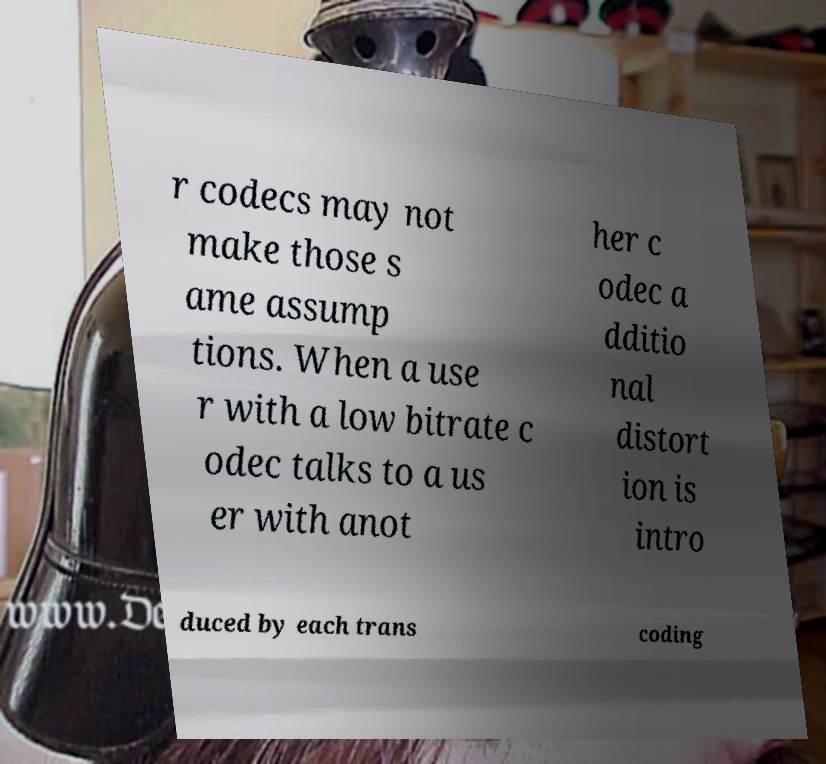Please identify and transcribe the text found in this image. r codecs may not make those s ame assump tions. When a use r with a low bitrate c odec talks to a us er with anot her c odec a dditio nal distort ion is intro duced by each trans coding 